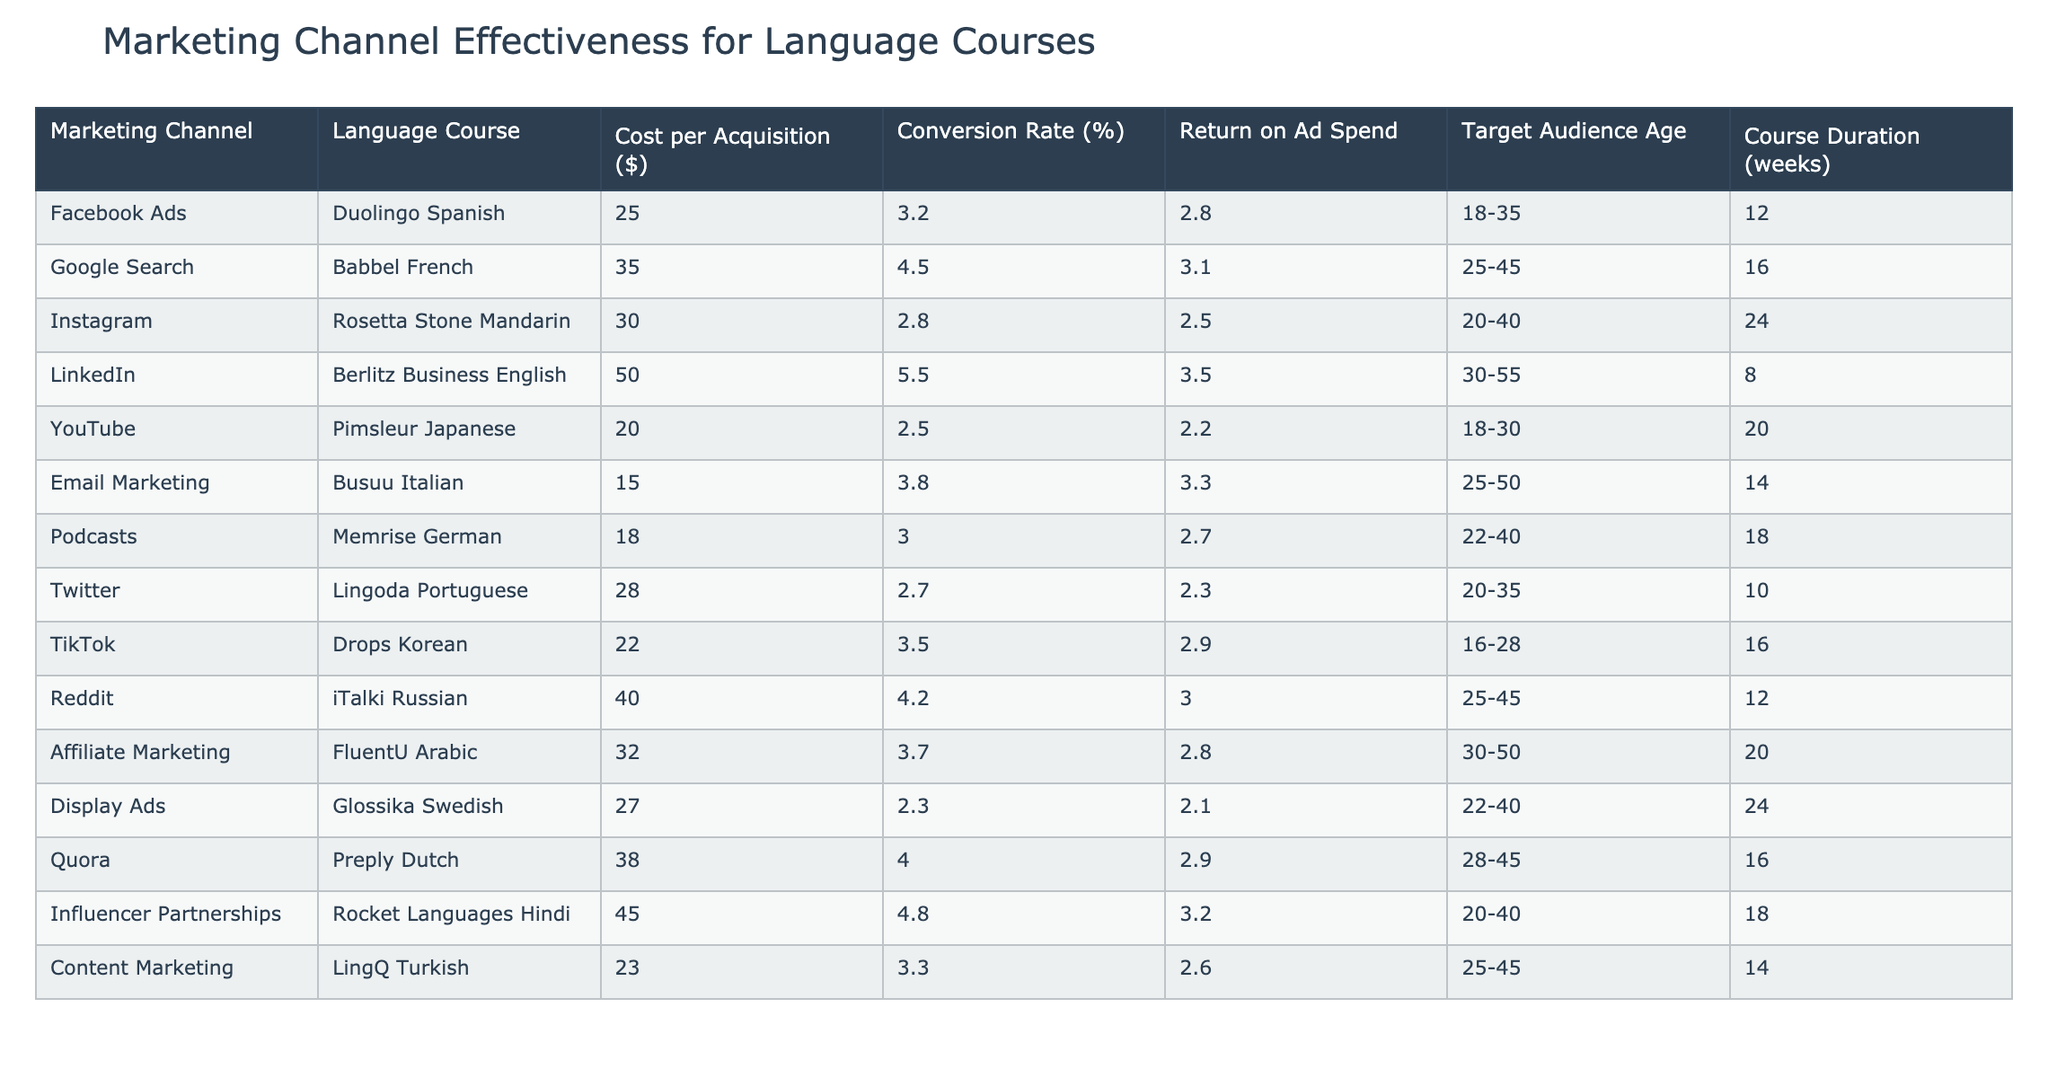What is the cost per acquisition for the Berlitz Business English course? The cost per acquisition is listed directly in the table under the "Cost per Acquisition ($)" column for the Berlitz Business English course, which is $50.
Answer: 50 Which marketing channel has the highest return on ad spend? To find the highest return on ad spend, we need to look at the "Return on Ad Spend" column and identify the maximum value. The highest value is 3.5 corresponding to LinkedIn for the Berlitz Business English course.
Answer: Berlitz Business English on LinkedIn What is the average conversion rate of all marketing channels listed? First, we add up all conversion rates from the "Conversion Rate (%)" column: (3.2 + 4.5 + 2.8 + 5.5 + 2.5 + 3.8 + 3.0 + 2.7 + 3.5 + 4.2 + 3.7 + 2.3 + 4.0 + 4.8 + 3.3) = 50.8. Then we divide by the total number of courses (15). So, the average conversion rate is 50.8 / 15 = 3.39.
Answer: 3.39 Is the cost per acquisition for the iTalki Russian course higher than the average across all courses? First, we find the cost per acquisition for the iTalki Russian course, which is $40. Then we calculate the average cost per acquisition across all courses: (25 + 35 + 30 + 50 + 20 + 15 + 18 + 28 + 22 + 40 + 32 + 27 + 38 + 45 + 23) =  28. and we divide by 15 to get approximately $28. The iTalki Russian course cost is higher than the average cost.
Answer: Yes Which language course targets the age group of 18-30 and has a conversion rate of at least 3%? Filtering through the table, we look for courses with a "Target Audience Age" of 18-30 and a "Conversion Rate (%)" of 3% or higher. The only option fitting these criteria is YouTube with the Pimsleur Japanese course at a conversion rate of 2.5%, which is not enough, hence none.
Answer: None 